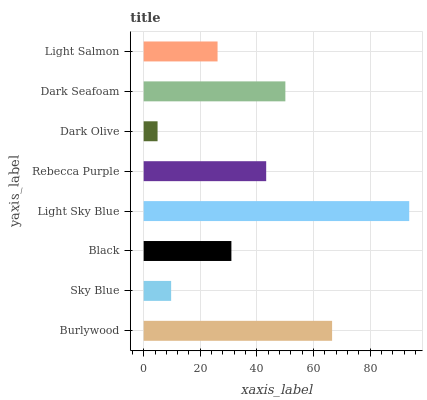Is Dark Olive the minimum?
Answer yes or no. Yes. Is Light Sky Blue the maximum?
Answer yes or no. Yes. Is Sky Blue the minimum?
Answer yes or no. No. Is Sky Blue the maximum?
Answer yes or no. No. Is Burlywood greater than Sky Blue?
Answer yes or no. Yes. Is Sky Blue less than Burlywood?
Answer yes or no. Yes. Is Sky Blue greater than Burlywood?
Answer yes or no. No. Is Burlywood less than Sky Blue?
Answer yes or no. No. Is Rebecca Purple the high median?
Answer yes or no. Yes. Is Black the low median?
Answer yes or no. Yes. Is Black the high median?
Answer yes or no. No. Is Light Sky Blue the low median?
Answer yes or no. No. 